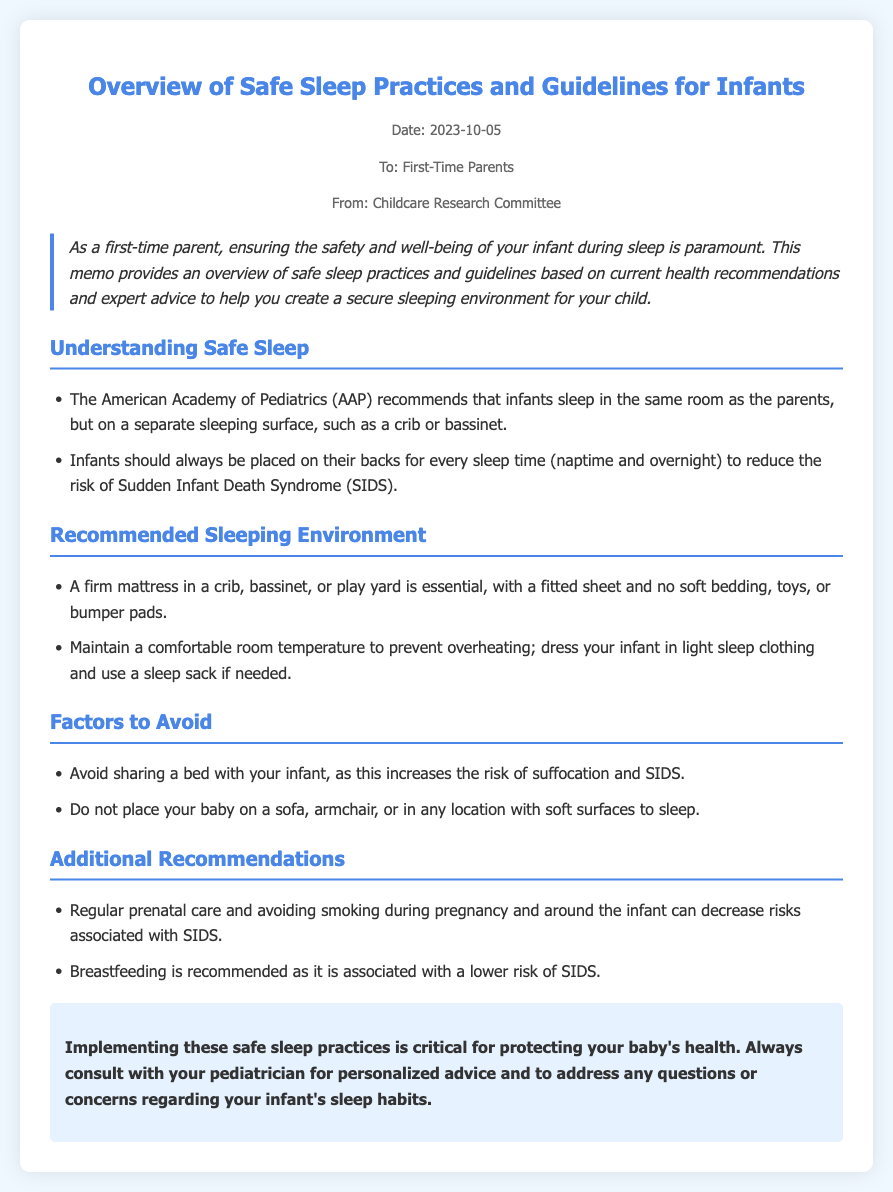What is the title of the memo? The title provides an overview of the content discussed in the memo, which is about safe sleep practices for infants.
Answer: Overview of Safe Sleep Practices and Guidelines for Infants Who is the memo addressed to? The memo specifies its target audience in the greeting, indicating who should read it.
Answer: First-Time Parents What is the date of the memo? The date helps to understand the timeliness of the information provided.
Answer: 2023-10-05 What is one recommendation for the sleeping surface of infants? The document outlines specific safe sleep guidelines, mentioning what the sleeping area should consist of.
Answer: A firm mattress What should you always do when placing an infant to sleep? This question addresses a crucial piece of guidance specified by health recommendations in the memo.
Answer: Place on their backs What should be avoided when putting your baby to sleep? The document details actions that can compromise infant safety, stating what to steer clear of.
Answer: Sharing a bed Why is breastfeeding recommended? This question probes into the reasoning behind one of the suggestions made in the document, seeking the relationship with infant safety.
Answer: Associated with a lower risk of SIDS What should mothers avoid during pregnancy to reduce risks? The memo lists factors that can negatively impact infant safety, including actions to be avoided during pregnancy.
Answer: Smoking What kind of temperature should the infant's room be maintained at? This identifies specific environmental conditions highlighted in the memo that contribute to safe sleep practices.
Answer: Comfortable room temperature 